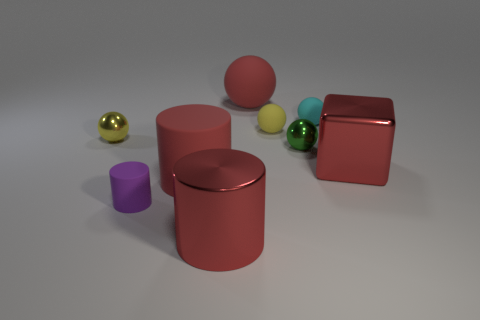Subtract all big cylinders. How many cylinders are left? 1 Subtract all red cylinders. How many cylinders are left? 1 Subtract all red cubes. How many red cylinders are left? 2 Subtract all blocks. How many objects are left? 8 Subtract 1 blocks. How many blocks are left? 0 Subtract 0 gray cubes. How many objects are left? 9 Subtract all cyan cylinders. Subtract all yellow cubes. How many cylinders are left? 3 Subtract all small cyan shiny blocks. Subtract all red balls. How many objects are left? 8 Add 3 purple matte objects. How many purple matte objects are left? 4 Add 7 blue metallic blocks. How many blue metallic blocks exist? 7 